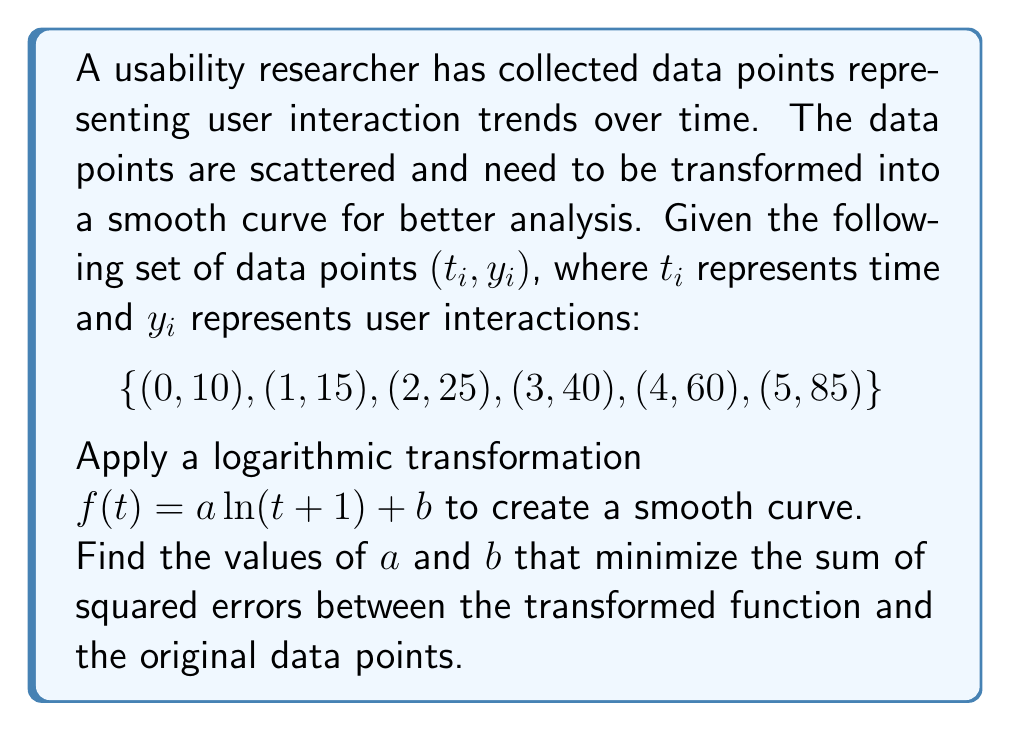Give your solution to this math problem. To solve this problem, we'll use the method of least squares to find the best-fit logarithmic curve. Here's a step-by-step approach:

1) The general form of our transformation is $f(t) = a \ln(t + 1) + b$.

2) We need to minimize the sum of squared errors:

   $$SSE = \sum_{i=1}^{6} [y_i - (a \ln(t_i + 1) + b)]^2$$

3) To minimize SSE, we take partial derivatives with respect to $a$ and $b$ and set them to zero:

   $$\frac{\partial SSE}{\partial a} = -2\sum_{i=1}^{6} [y_i - (a \ln(t_i + 1) + b)] \ln(t_i + 1) = 0$$
   $$\frac{\partial SSE}{\partial b} = -2\sum_{i=1}^{6} [y_i - (a \ln(t_i + 1) + b)] = 0$$

4) Simplifying these equations:

   $$\sum_{i=1}^{6} y_i \ln(t_i + 1) = a \sum_{i=1}^{6} [\ln(t_i + 1)]^2 + b \sum_{i=1}^{6} \ln(t_i + 1)$$
   $$\sum_{i=1}^{6} y_i = a \sum_{i=1}^{6} \ln(t_i + 1) + 6b$$

5) Calculate the sums:
   
   $\sum y_i = 235$
   $\sum \ln(t_i + 1) = 7.0190$
   $\sum y_i \ln(t_i + 1) = 280.7598$
   $\sum [\ln(t_i + 1)]^2 = 11.3455$

6) Substitute these values into our equations:

   $280.7598 = 11.3455a + 7.0190b$
   $235 = 7.0190a + 6b$

7) Solve this system of equations:
   
   $a = 44.7215$
   $b = 10.5384$

Therefore, the best-fit logarithmic transformation is:

$$f(t) = 44.7215 \ln(t + 1) + 10.5384$$
Answer: $f(t) = 44.7215 \ln(t + 1) + 10.5384$ 